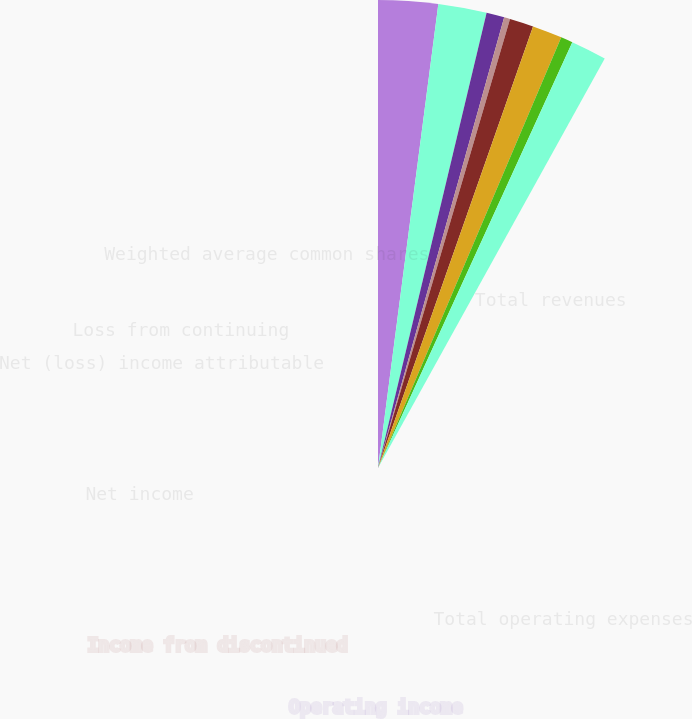<chart> <loc_0><loc_0><loc_500><loc_500><pie_chart><fcel>Total revenues<fcel>Total operating expenses<fcel>Operating income<fcel>(Loss) income from continuing<fcel>Income from discontinued<fcel>Net income<fcel>Net (loss) income attributable<fcel>Loss from continuing<fcel>Weighted average common shares<nl><fcel>25.57%<fcel>20.74%<fcel>7.67%<fcel>2.56%<fcel>10.23%<fcel>12.78%<fcel>5.11%<fcel>0.0%<fcel>15.34%<nl></chart> 